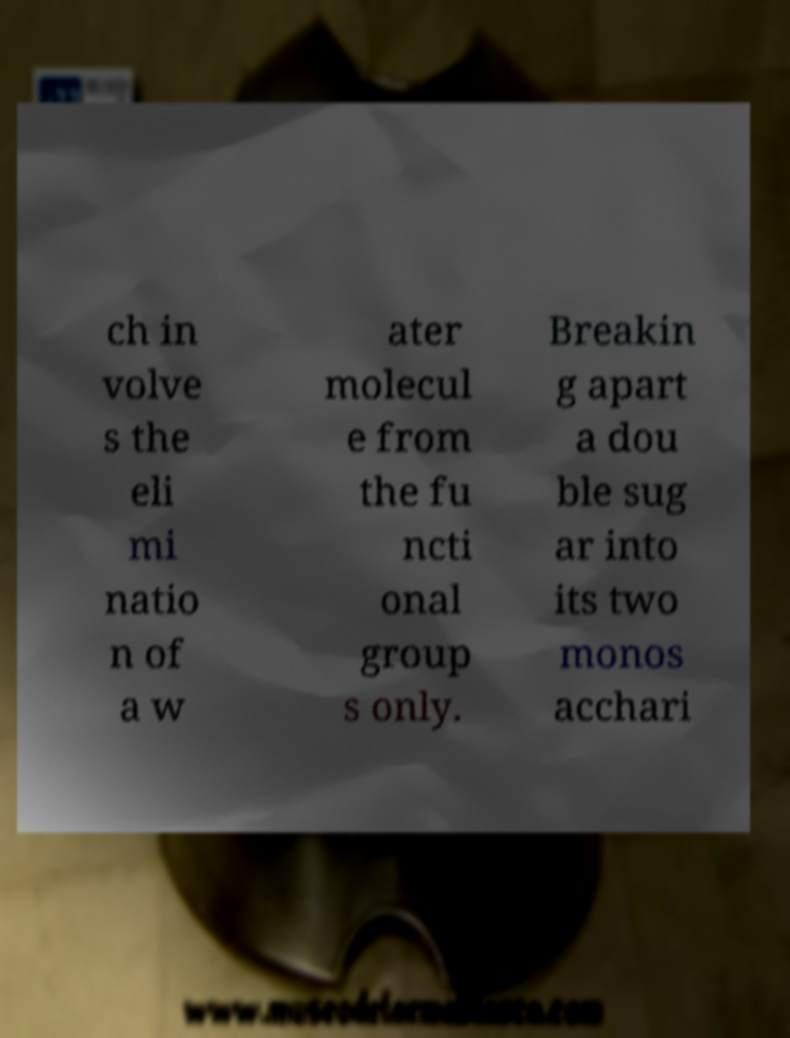What messages or text are displayed in this image? I need them in a readable, typed format. ch in volve s the eli mi natio n of a w ater molecul e from the fu ncti onal group s only. Breakin g apart a dou ble sug ar into its two monos acchari 